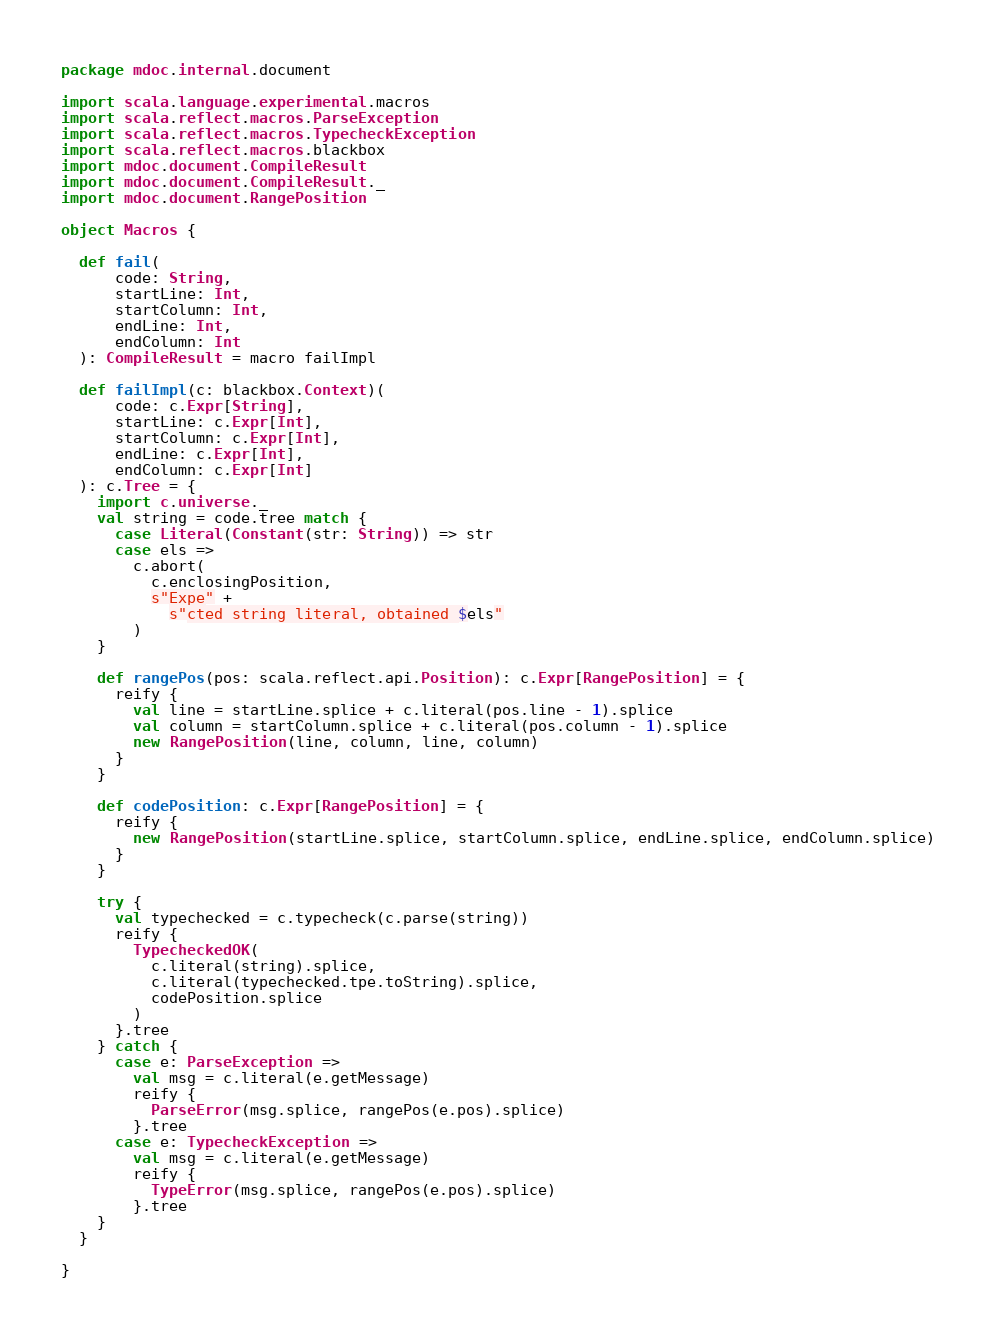<code> <loc_0><loc_0><loc_500><loc_500><_Scala_>package mdoc.internal.document

import scala.language.experimental.macros
import scala.reflect.macros.ParseException
import scala.reflect.macros.TypecheckException
import scala.reflect.macros.blackbox
import mdoc.document.CompileResult
import mdoc.document.CompileResult._
import mdoc.document.RangePosition

object Macros {

  def fail(
      code: String,
      startLine: Int,
      startColumn: Int,
      endLine: Int,
      endColumn: Int
  ): CompileResult = macro failImpl

  def failImpl(c: blackbox.Context)(
      code: c.Expr[String],
      startLine: c.Expr[Int],
      startColumn: c.Expr[Int],
      endLine: c.Expr[Int],
      endColumn: c.Expr[Int]
  ): c.Tree = {
    import c.universe._
    val string = code.tree match {
      case Literal(Constant(str: String)) => str
      case els =>
        c.abort(
          c.enclosingPosition,
          s"Expe" +
            s"cted string literal, obtained $els"
        )
    }

    def rangePos(pos: scala.reflect.api.Position): c.Expr[RangePosition] = {
      reify {
        val line = startLine.splice + c.literal(pos.line - 1).splice
        val column = startColumn.splice + c.literal(pos.column - 1).splice
        new RangePosition(line, column, line, column)
      }
    }

    def codePosition: c.Expr[RangePosition] = {
      reify {
        new RangePosition(startLine.splice, startColumn.splice, endLine.splice, endColumn.splice)
      }
    }

    try {
      val typechecked = c.typecheck(c.parse(string))
      reify {
        TypecheckedOK(
          c.literal(string).splice,
          c.literal(typechecked.tpe.toString).splice,
          codePosition.splice
        )
      }.tree
    } catch {
      case e: ParseException =>
        val msg = c.literal(e.getMessage)
        reify {
          ParseError(msg.splice, rangePos(e.pos).splice)
        }.tree
      case e: TypecheckException =>
        val msg = c.literal(e.getMessage)
        reify {
          TypeError(msg.splice, rangePos(e.pos).splice)
        }.tree
    }
  }

}
</code> 